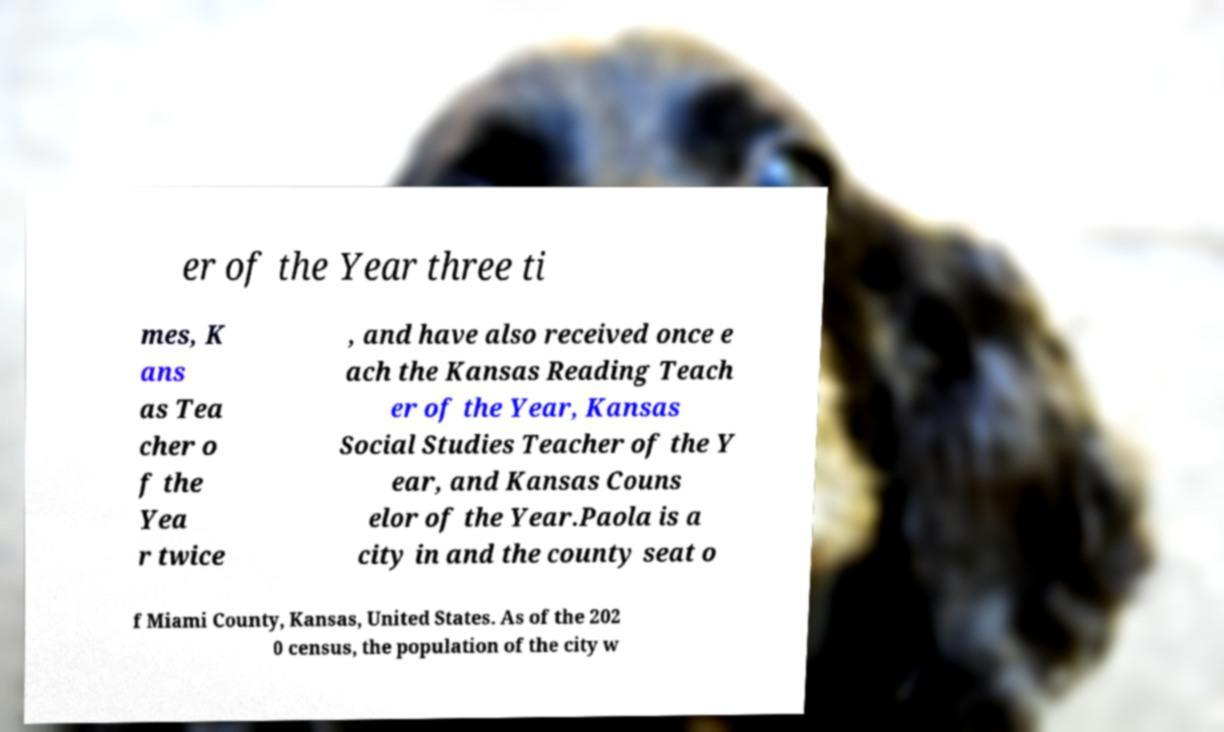There's text embedded in this image that I need extracted. Can you transcribe it verbatim? er of the Year three ti mes, K ans as Tea cher o f the Yea r twice , and have also received once e ach the Kansas Reading Teach er of the Year, Kansas Social Studies Teacher of the Y ear, and Kansas Couns elor of the Year.Paola is a city in and the county seat o f Miami County, Kansas, United States. As of the 202 0 census, the population of the city w 